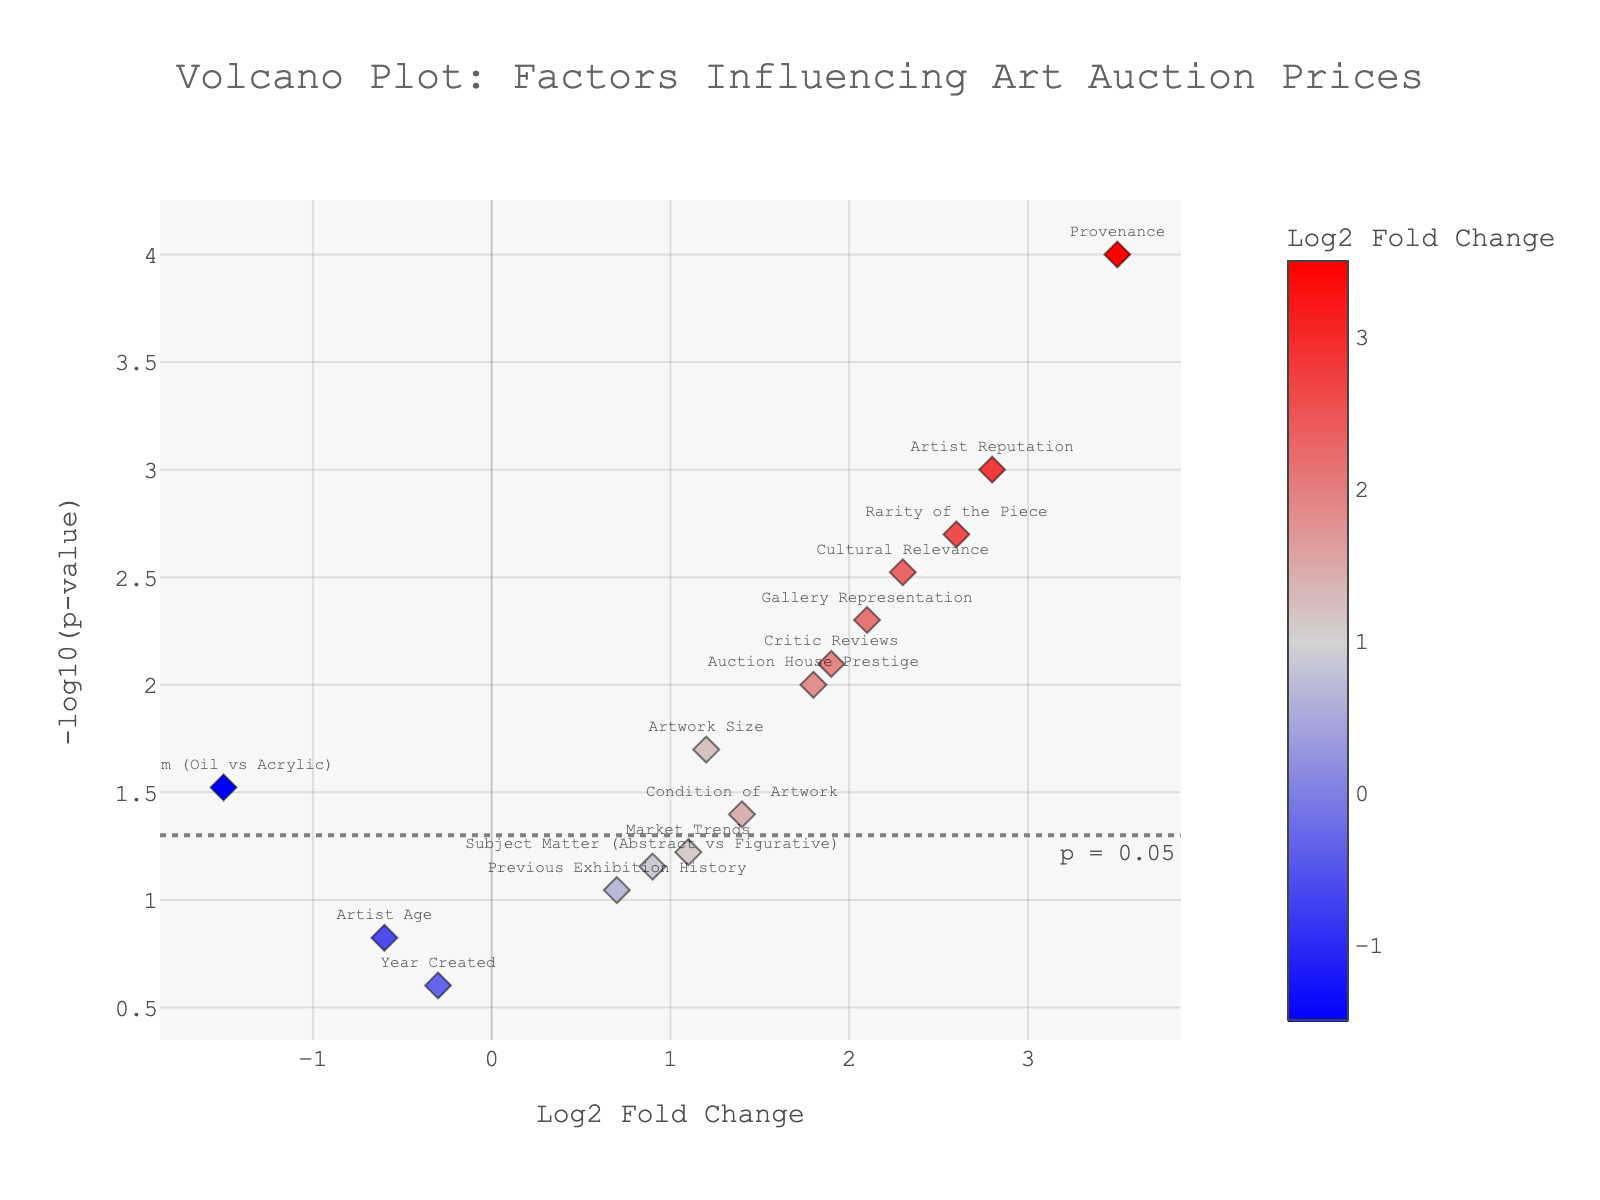What is the title of the plot? The title is usually located at the top center of the plot and often summarizes what the plot is about. Here, the title is "Volcano Plot: Factors Influencing Art Auction Prices."
Answer: Volcano Plot: Factors Influencing Art Auction Prices Which factor has the highest -log10(p-value) and what does it signify? To identify the factor with the highest -log10(p-value), look for the point positioned highest on the y-axis. In this plot, "Provenance" has the highest -log10(p-value). This indicates it’s the most statistically significant factor.
Answer: Provenance How many factors are statistically significant at p<0.05? Count the number of points above the horizontal dashed line representing the significance threshold (p = 0.05). The factors above this line are significant. There are 9 such factors above the line.
Answer: 9 Which factor has the highest positive Log2 Fold Change value? Look for the point farthest to the right on the x-axis since positive Log2 Fold Change values are on the right side. "Provenance" has the highest positive Log2 Fold Change value.
Answer: Provenance What is the Log2 Fold Change value for the "Artist Reputation" factor? Locate the point labeled "Artist Reputation" and check its position on the x-axis. The Log2 Fold Change value for "Artist Reputation" is approximately 2.8.
Answer: 2.8 Compare "Market Trends" and "Cultural Relevance" in terms of statistical significance. Which is more significant? For statistical significance, compare their y-axis positions. "Cultural Relevance" has a higher -log10(p-value) value than "Market Trends," indicating it is more statistically significant.
Answer: Cultural Relevance Which factor suggests a negative impact on art auction prices and is also statistically significant? Look for points with negative Log2 Fold Change values (on the left side of the x-axis) that are also above the p<0.05 threshold line. "Medium (Oil vs Acrylic)" meets these criteria.
Answer: Medium (Oil vs Acrylic) What does the color of the points represent in the plot? The colors range from blue for negative values, light grey for values close to zero, to red for positive values, representing Log2 Fold Change.
Answer: Log2 Fold Change Compare "Previous Exhibition History" to "Artist Reputation" in terms of their Log2 Fold Change values. Which one has a higher value? Locate both points on the x-axis and compare their positions. "Artist Reputation" is farther to the right, indicating a higher Log2 Fold Change value than "Previous Exhibition History."
Answer: Artist Reputation 